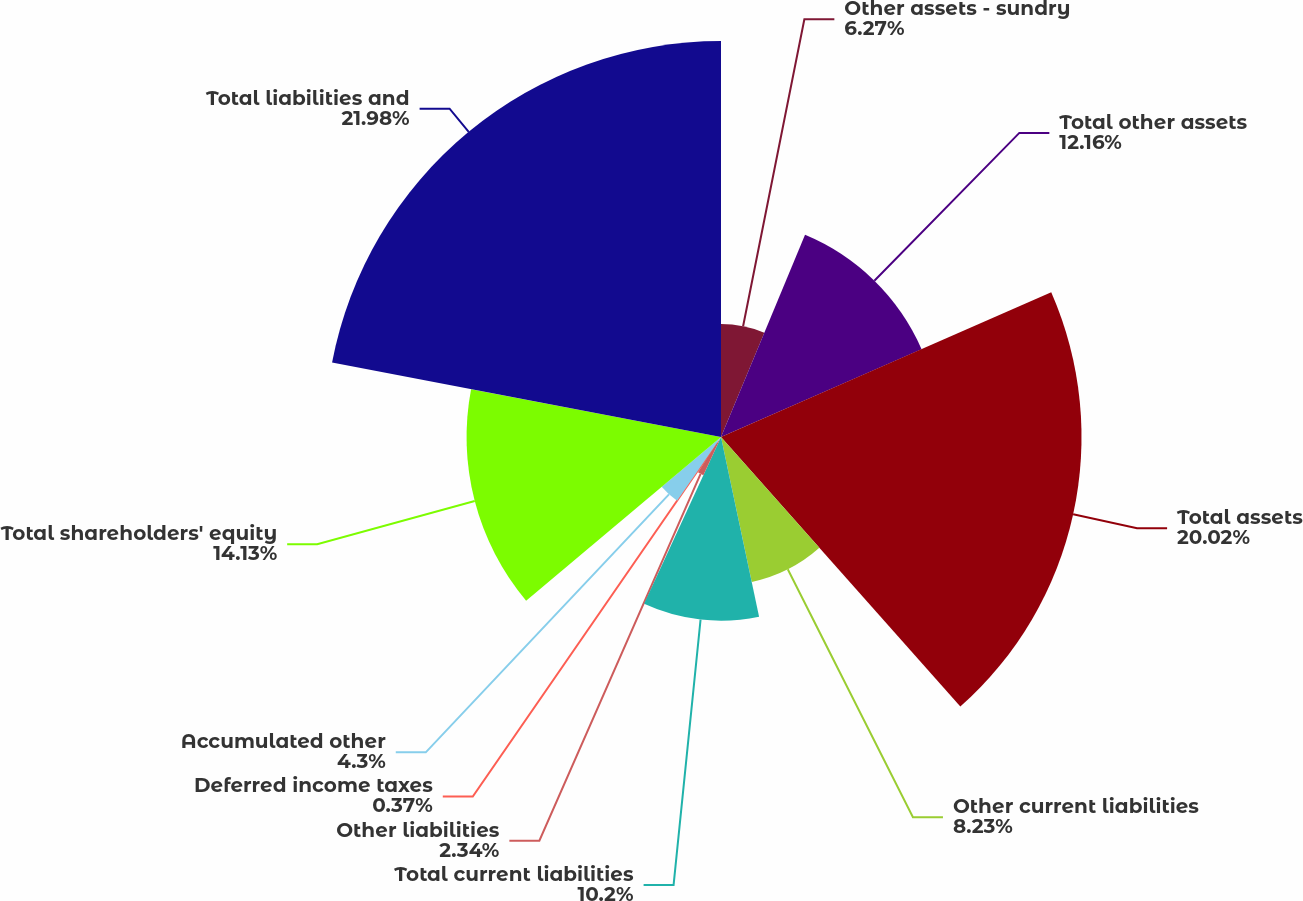Convert chart to OTSL. <chart><loc_0><loc_0><loc_500><loc_500><pie_chart><fcel>Other assets - sundry<fcel>Total other assets<fcel>Total assets<fcel>Other current liabilities<fcel>Total current liabilities<fcel>Other liabilities<fcel>Deferred income taxes<fcel>Accumulated other<fcel>Total shareholders' equity<fcel>Total liabilities and<nl><fcel>6.27%<fcel>12.16%<fcel>20.02%<fcel>8.23%<fcel>10.2%<fcel>2.34%<fcel>0.37%<fcel>4.3%<fcel>14.13%<fcel>21.99%<nl></chart> 